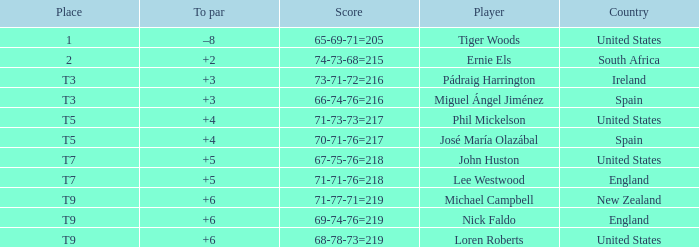What is Player, when Place is "1"? Tiger Woods. 